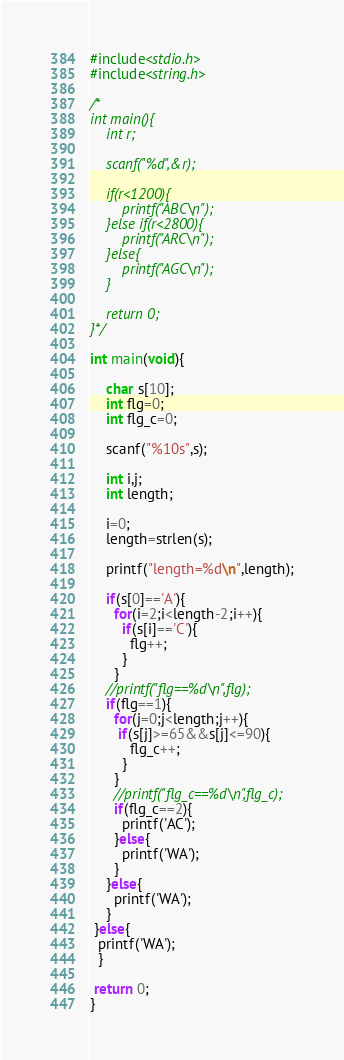Convert code to text. <code><loc_0><loc_0><loc_500><loc_500><_C_>#include<stdio.h>
#include<string.h>

/*
int main(){
    int r;

    scanf("%d",&r);

    if(r<1200){
        printf("ABC\n");
    }else if(r<2800){
        printf("ARC\n");
    }else{
        printf("AGC\n");
    }

    return 0;
}*/

int main(void){

    char s[10];
    int flg=0;
    int flg_c=0;

    scanf("%10s",s);

    int i,j;
    int length;

    i=0;
    length=strlen(s);

    printf("length=%d\n",length);

    if(s[0]=='A'){
      for(i=2;i<length-2;i++){
        if(s[i]=='C'){
          flg++;
        }
      }
    //printf("flg==%d\n",flg);
    if(flg==1){
      for(j=0;j<length;j++){
       if(s[j]>=65&&s[j]<=90){
          flg_c++;
        }
      }
      //printf("flg_c==%d\n",flg_c);
      if(flg_c==2){
        printf('AC');
      }else{
        printf('WA');
      }
    }else{
      printf('WA');
    }
 }else{
  printf('WA');
  }

 return 0;
}
</code> 